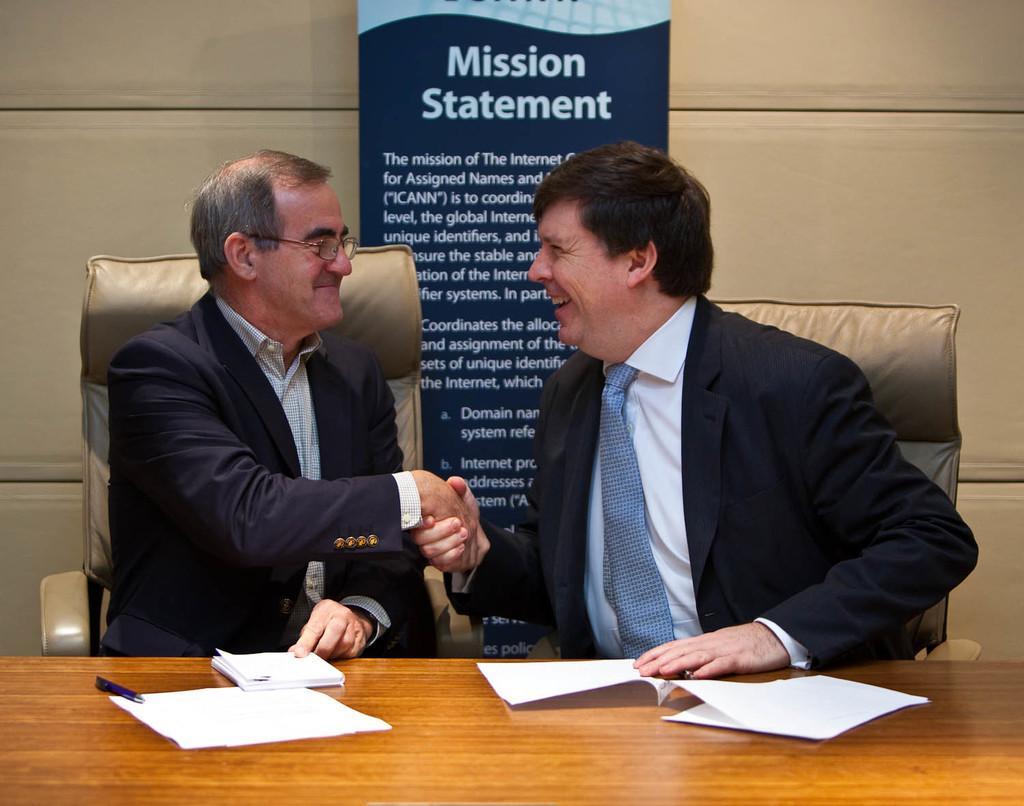Can you describe this image briefly? Here a man is sitting on the chair, he wore a black color coat and smiling, shaking hands with the man who is sitting in the right side. There are papers on this table. 